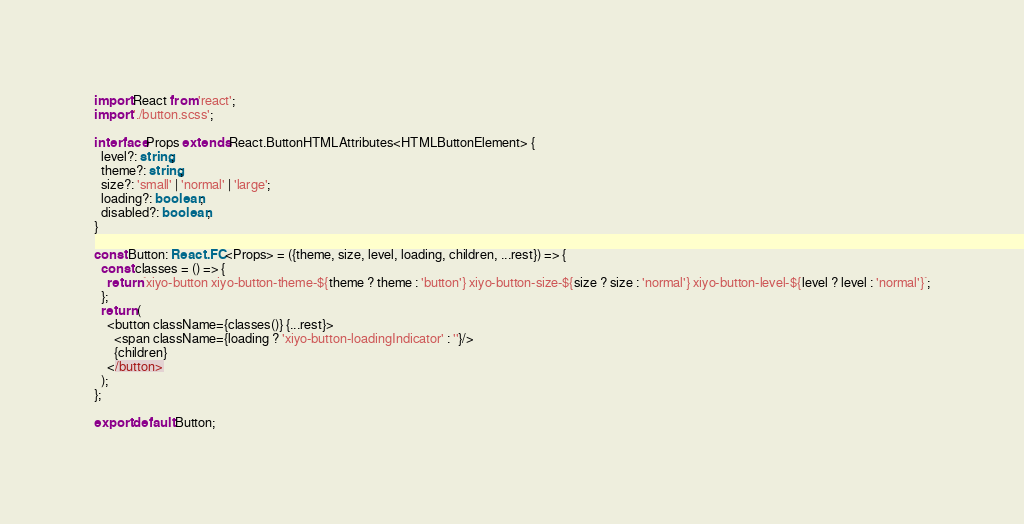Convert code to text. <code><loc_0><loc_0><loc_500><loc_500><_TypeScript_>import React from 'react';
import './button.scss';

interface Props extends React.ButtonHTMLAttributes<HTMLButtonElement> {
  level?: string;
  theme?: string;
  size?: 'small' | 'normal' | 'large';
  loading?: boolean;
  disabled?: boolean;
}

const Button: React.FC<Props> = ({theme, size, level, loading, children, ...rest}) => {
  const classes = () => {
    return `xiyo-button xiyo-button-theme-${theme ? theme : 'button'} xiyo-button-size-${size ? size : 'normal'} xiyo-button-level-${level ? level : 'normal'}`;
  };
  return (
    <button className={classes()} {...rest}>
      <span className={loading ? 'xiyo-button-loadingIndicator' : ''}/>
      {children}
    </button>
  );
};

export default Button;</code> 